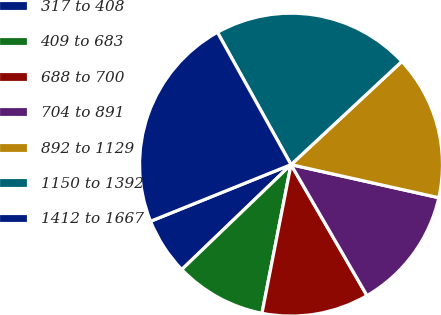<chart> <loc_0><loc_0><loc_500><loc_500><pie_chart><fcel>317 to 408<fcel>409 to 683<fcel>688 to 700<fcel>704 to 891<fcel>892 to 1129<fcel>1150 to 1392<fcel>1412 to 1667<nl><fcel>6.08%<fcel>9.75%<fcel>11.44%<fcel>13.13%<fcel>15.44%<fcel>21.15%<fcel>23.02%<nl></chart> 